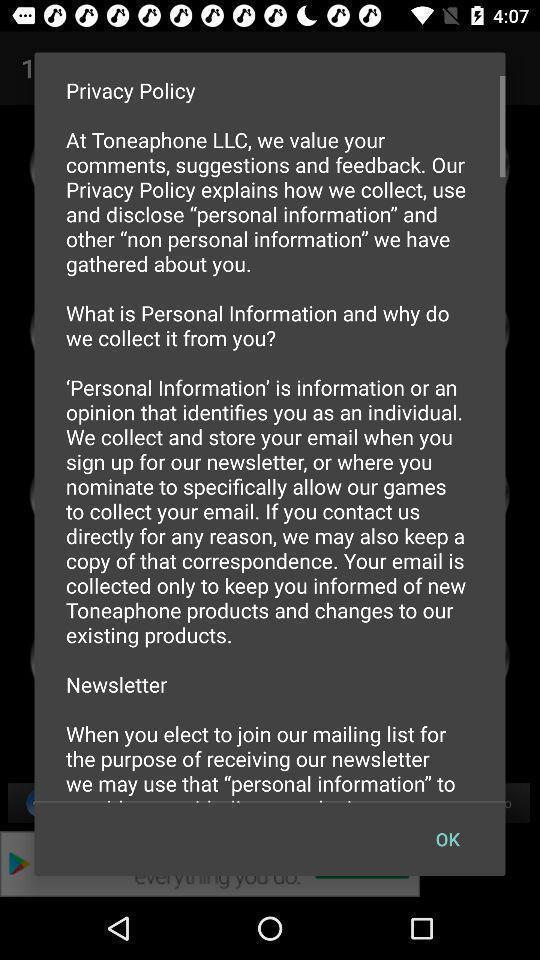What is the overall content of this screenshot? Page showing details about privacy policy. 